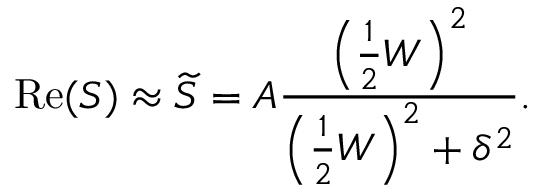<formula> <loc_0><loc_0><loc_500><loc_500>R e ( S ) \approx \widetilde { S } = A \frac { \left ( \frac { 1 } { 2 } W \right ) ^ { 2 } } { \left ( \frac { 1 } { 2 } W \right ) ^ { 2 } + \delta ^ { 2 } } .</formula> 